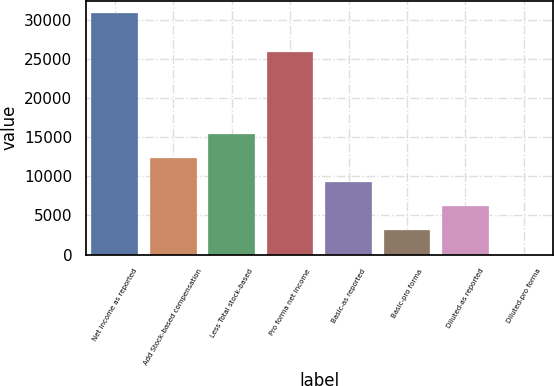<chart> <loc_0><loc_0><loc_500><loc_500><bar_chart><fcel>Net income as reported<fcel>Add Stock-based compensation<fcel>Less Total stock-based<fcel>Pro forma net income<fcel>Basic-as reported<fcel>Basic-pro forma<fcel>Diluted-as reported<fcel>Diluted-pro forma<nl><fcel>30887<fcel>12355<fcel>15443.6<fcel>25899<fcel>9266.28<fcel>3088.94<fcel>6177.61<fcel>0.27<nl></chart> 